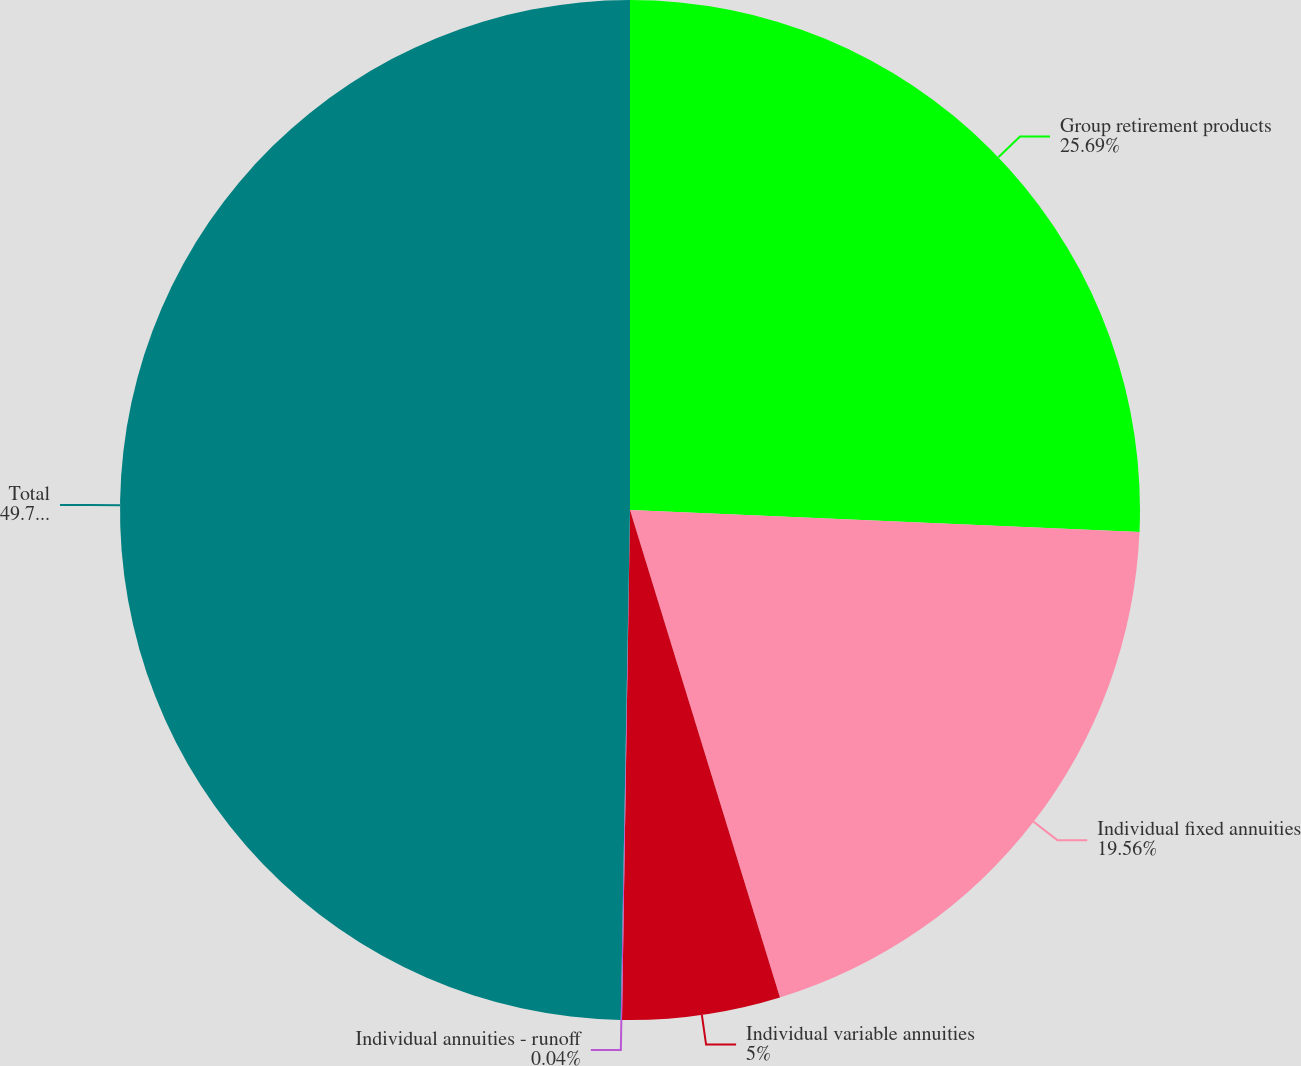Convert chart to OTSL. <chart><loc_0><loc_0><loc_500><loc_500><pie_chart><fcel>Group retirement products<fcel>Individual fixed annuities<fcel>Individual variable annuities<fcel>Individual annuities - runoff<fcel>Total<nl><fcel>25.69%<fcel>19.56%<fcel>5.0%<fcel>0.04%<fcel>49.71%<nl></chart> 